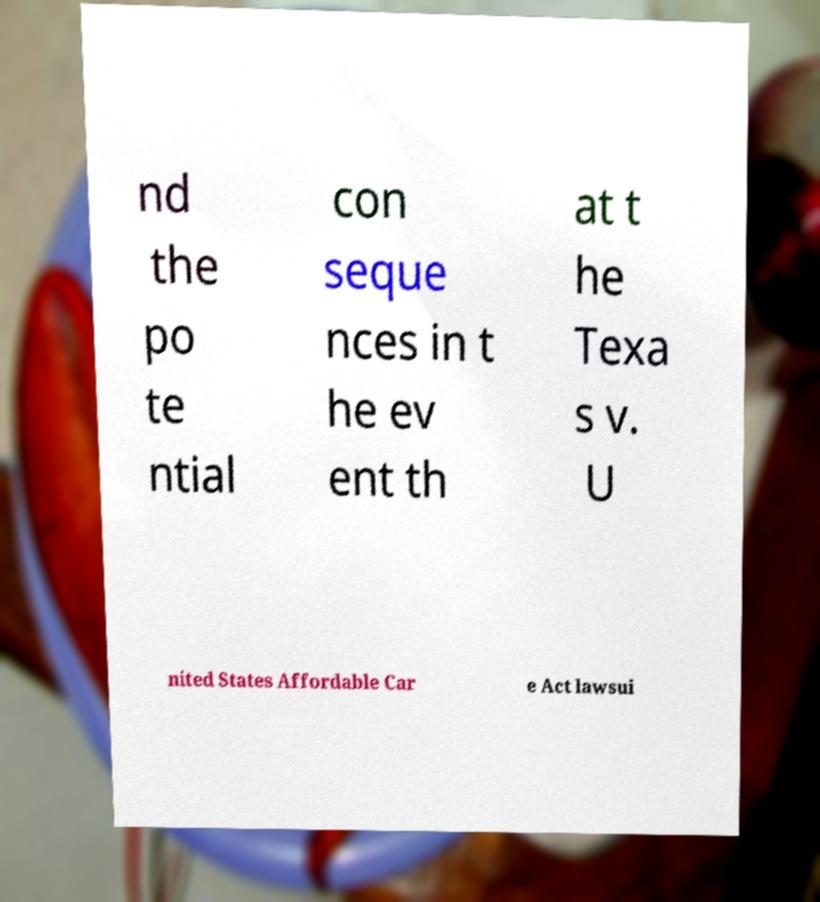Could you extract and type out the text from this image? nd the po te ntial con seque nces in t he ev ent th at t he Texa s v. U nited States Affordable Car e Act lawsui 